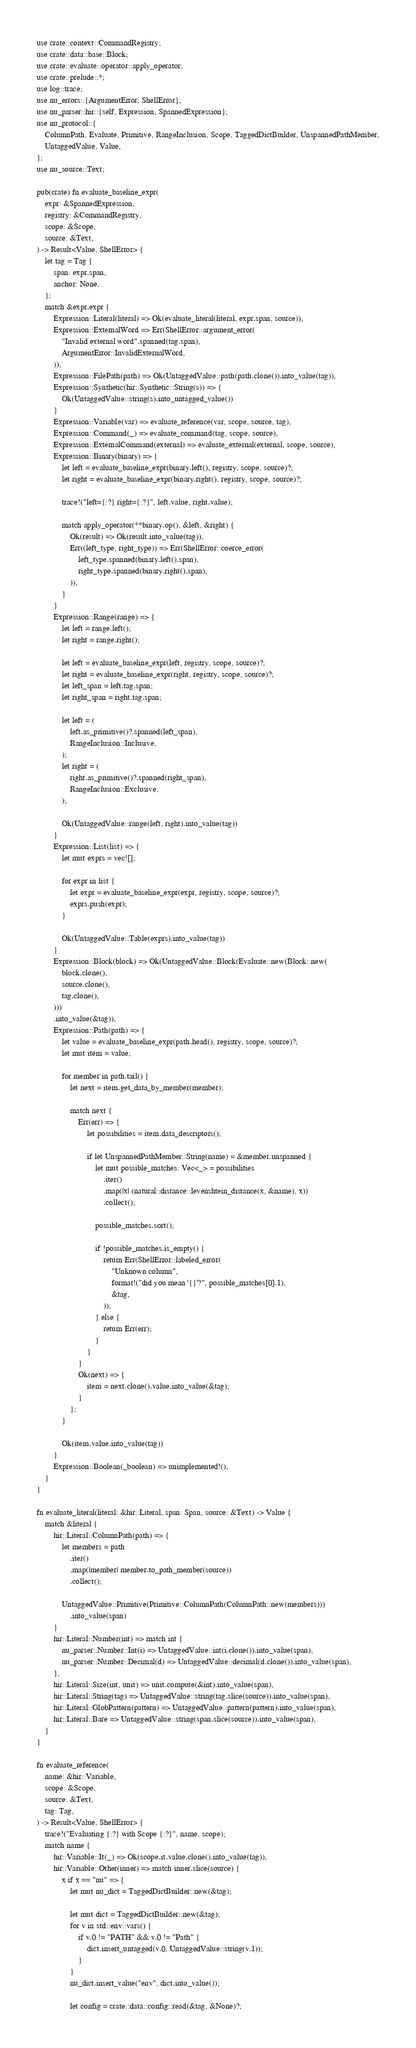<code> <loc_0><loc_0><loc_500><loc_500><_Rust_>use crate::context::CommandRegistry;
use crate::data::base::Block;
use crate::evaluate::operator::apply_operator;
use crate::prelude::*;
use log::trace;
use nu_errors::{ArgumentError, ShellError};
use nu_parser::hir::{self, Expression, SpannedExpression};
use nu_protocol::{
    ColumnPath, Evaluate, Primitive, RangeInclusion, Scope, TaggedDictBuilder, UnspannedPathMember,
    UntaggedValue, Value,
};
use nu_source::Text;

pub(crate) fn evaluate_baseline_expr(
    expr: &SpannedExpression,
    registry: &CommandRegistry,
    scope: &Scope,
    source: &Text,
) -> Result<Value, ShellError> {
    let tag = Tag {
        span: expr.span,
        anchor: None,
    };
    match &expr.expr {
        Expression::Literal(literal) => Ok(evaluate_literal(literal, expr.span, source)),
        Expression::ExternalWord => Err(ShellError::argument_error(
            "Invalid external word".spanned(tag.span),
            ArgumentError::InvalidExternalWord,
        )),
        Expression::FilePath(path) => Ok(UntaggedValue::path(path.clone()).into_value(tag)),
        Expression::Synthetic(hir::Synthetic::String(s)) => {
            Ok(UntaggedValue::string(s).into_untagged_value())
        }
        Expression::Variable(var) => evaluate_reference(var, scope, source, tag),
        Expression::Command(_) => evaluate_command(tag, scope, source),
        Expression::ExternalCommand(external) => evaluate_external(external, scope, source),
        Expression::Binary(binary) => {
            let left = evaluate_baseline_expr(binary.left(), registry, scope, source)?;
            let right = evaluate_baseline_expr(binary.right(), registry, scope, source)?;

            trace!("left={:?} right={:?}", left.value, right.value);

            match apply_operator(**binary.op(), &left, &right) {
                Ok(result) => Ok(result.into_value(tag)),
                Err((left_type, right_type)) => Err(ShellError::coerce_error(
                    left_type.spanned(binary.left().span),
                    right_type.spanned(binary.right().span),
                )),
            }
        }
        Expression::Range(range) => {
            let left = range.left();
            let right = range.right();

            let left = evaluate_baseline_expr(left, registry, scope, source)?;
            let right = evaluate_baseline_expr(right, registry, scope, source)?;
            let left_span = left.tag.span;
            let right_span = right.tag.span;

            let left = (
                left.as_primitive()?.spanned(left_span),
                RangeInclusion::Inclusive,
            );
            let right = (
                right.as_primitive()?.spanned(right_span),
                RangeInclusion::Exclusive,
            );

            Ok(UntaggedValue::range(left, right).into_value(tag))
        }
        Expression::List(list) => {
            let mut exprs = vec![];

            for expr in list {
                let expr = evaluate_baseline_expr(expr, registry, scope, source)?;
                exprs.push(expr);
            }

            Ok(UntaggedValue::Table(exprs).into_value(tag))
        }
        Expression::Block(block) => Ok(UntaggedValue::Block(Evaluate::new(Block::new(
            block.clone(),
            source.clone(),
            tag.clone(),
        )))
        .into_value(&tag)),
        Expression::Path(path) => {
            let value = evaluate_baseline_expr(path.head(), registry, scope, source)?;
            let mut item = value;

            for member in path.tail() {
                let next = item.get_data_by_member(member);

                match next {
                    Err(err) => {
                        let possibilities = item.data_descriptors();

                        if let UnspannedPathMember::String(name) = &member.unspanned {
                            let mut possible_matches: Vec<_> = possibilities
                                .iter()
                                .map(|x| (natural::distance::levenshtein_distance(x, &name), x))
                                .collect();

                            possible_matches.sort();

                            if !possible_matches.is_empty() {
                                return Err(ShellError::labeled_error(
                                    "Unknown column",
                                    format!("did you mean '{}'?", possible_matches[0].1),
                                    &tag,
                                ));
                            } else {
                                return Err(err);
                            }
                        }
                    }
                    Ok(next) => {
                        item = next.clone().value.into_value(&tag);
                    }
                };
            }

            Ok(item.value.into_value(tag))
        }
        Expression::Boolean(_boolean) => unimplemented!(),
    }
}

fn evaluate_literal(literal: &hir::Literal, span: Span, source: &Text) -> Value {
    match &literal {
        hir::Literal::ColumnPath(path) => {
            let members = path
                .iter()
                .map(|member| member.to_path_member(source))
                .collect();

            UntaggedValue::Primitive(Primitive::ColumnPath(ColumnPath::new(members)))
                .into_value(span)
        }
        hir::Literal::Number(int) => match int {
            nu_parser::Number::Int(i) => UntaggedValue::int(i.clone()).into_value(span),
            nu_parser::Number::Decimal(d) => UntaggedValue::decimal(d.clone()).into_value(span),
        },
        hir::Literal::Size(int, unit) => unit.compute(&int).into_value(span),
        hir::Literal::String(tag) => UntaggedValue::string(tag.slice(source)).into_value(span),
        hir::Literal::GlobPattern(pattern) => UntaggedValue::pattern(pattern).into_value(span),
        hir::Literal::Bare => UntaggedValue::string(span.slice(source)).into_value(span),
    }
}

fn evaluate_reference(
    name: &hir::Variable,
    scope: &Scope,
    source: &Text,
    tag: Tag,
) -> Result<Value, ShellError> {
    trace!("Evaluating {:?} with Scope {:?}", name, scope);
    match name {
        hir::Variable::It(_) => Ok(scope.it.value.clone().into_value(tag)),
        hir::Variable::Other(inner) => match inner.slice(source) {
            x if x == "nu" => {
                let mut nu_dict = TaggedDictBuilder::new(&tag);

                let mut dict = TaggedDictBuilder::new(&tag);
                for v in std::env::vars() {
                    if v.0 != "PATH" && v.0 != "Path" {
                        dict.insert_untagged(v.0, UntaggedValue::string(v.1));
                    }
                }
                nu_dict.insert_value("env", dict.into_value());

                let config = crate::data::config::read(&tag, &None)?;</code> 